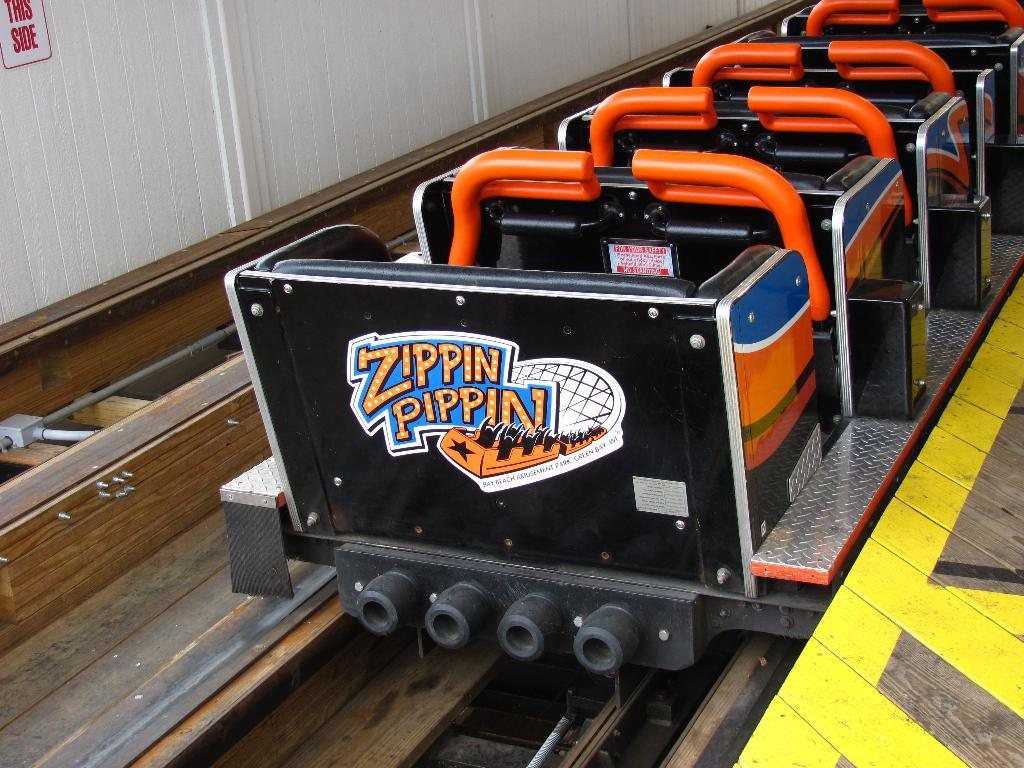What is the main subject of the image? The main subject of the image is a roller coaster. Can you describe the roller coaster's structure? The roller coaster is on tracks. What else can be seen in the background of the image? There is a sign board visible in the background of the image. Where is the sign board located? The sign board is on a wall. How many necks can be seen on the roller coaster in the image? There are no necks present on the roller coaster in the image; it is a mechanical structure. 